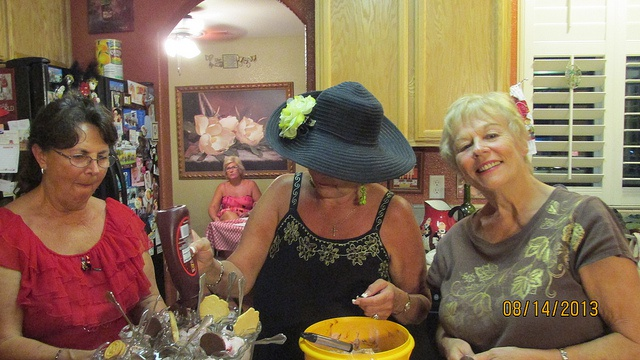Describe the objects in this image and their specific colors. I can see people in olive, black, gray, and brown tones, people in olive, gray, tan, and black tones, people in olive, brown, maroon, gray, and black tones, refrigerator in olive, black, gray, darkgray, and tan tones, and bowl in olive, orange, and gold tones in this image. 